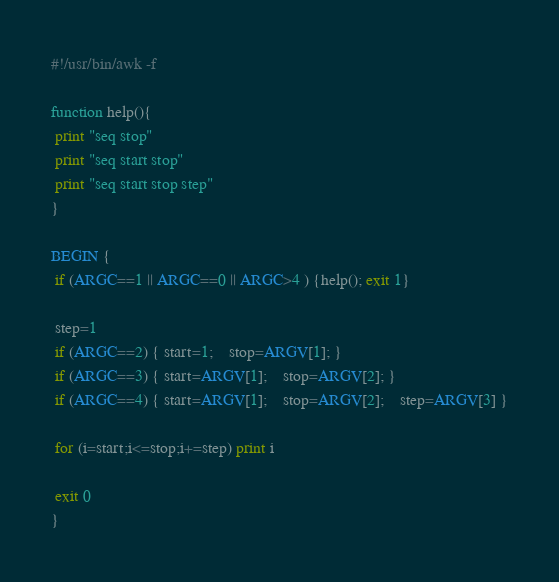Convert code to text. <code><loc_0><loc_0><loc_500><loc_500><_Awk_>#!/usr/bin/awk -f

function help(){
 print "seq stop"
 print "seq start stop"
 print "seq start stop step"
}

BEGIN {
 if (ARGC==1 || ARGC==0 || ARGC>4 ) {help(); exit 1}

 step=1
 if (ARGC==2) { start=1;	stop=ARGV[1]; }
 if (ARGC==3) { start=ARGV[1];	stop=ARGV[2]; }
 if (ARGC==4) { start=ARGV[1];	stop=ARGV[2];	step=ARGV[3] }

 for (i=start;i<=stop;i+=step) print i
 
 exit 0
}
</code> 